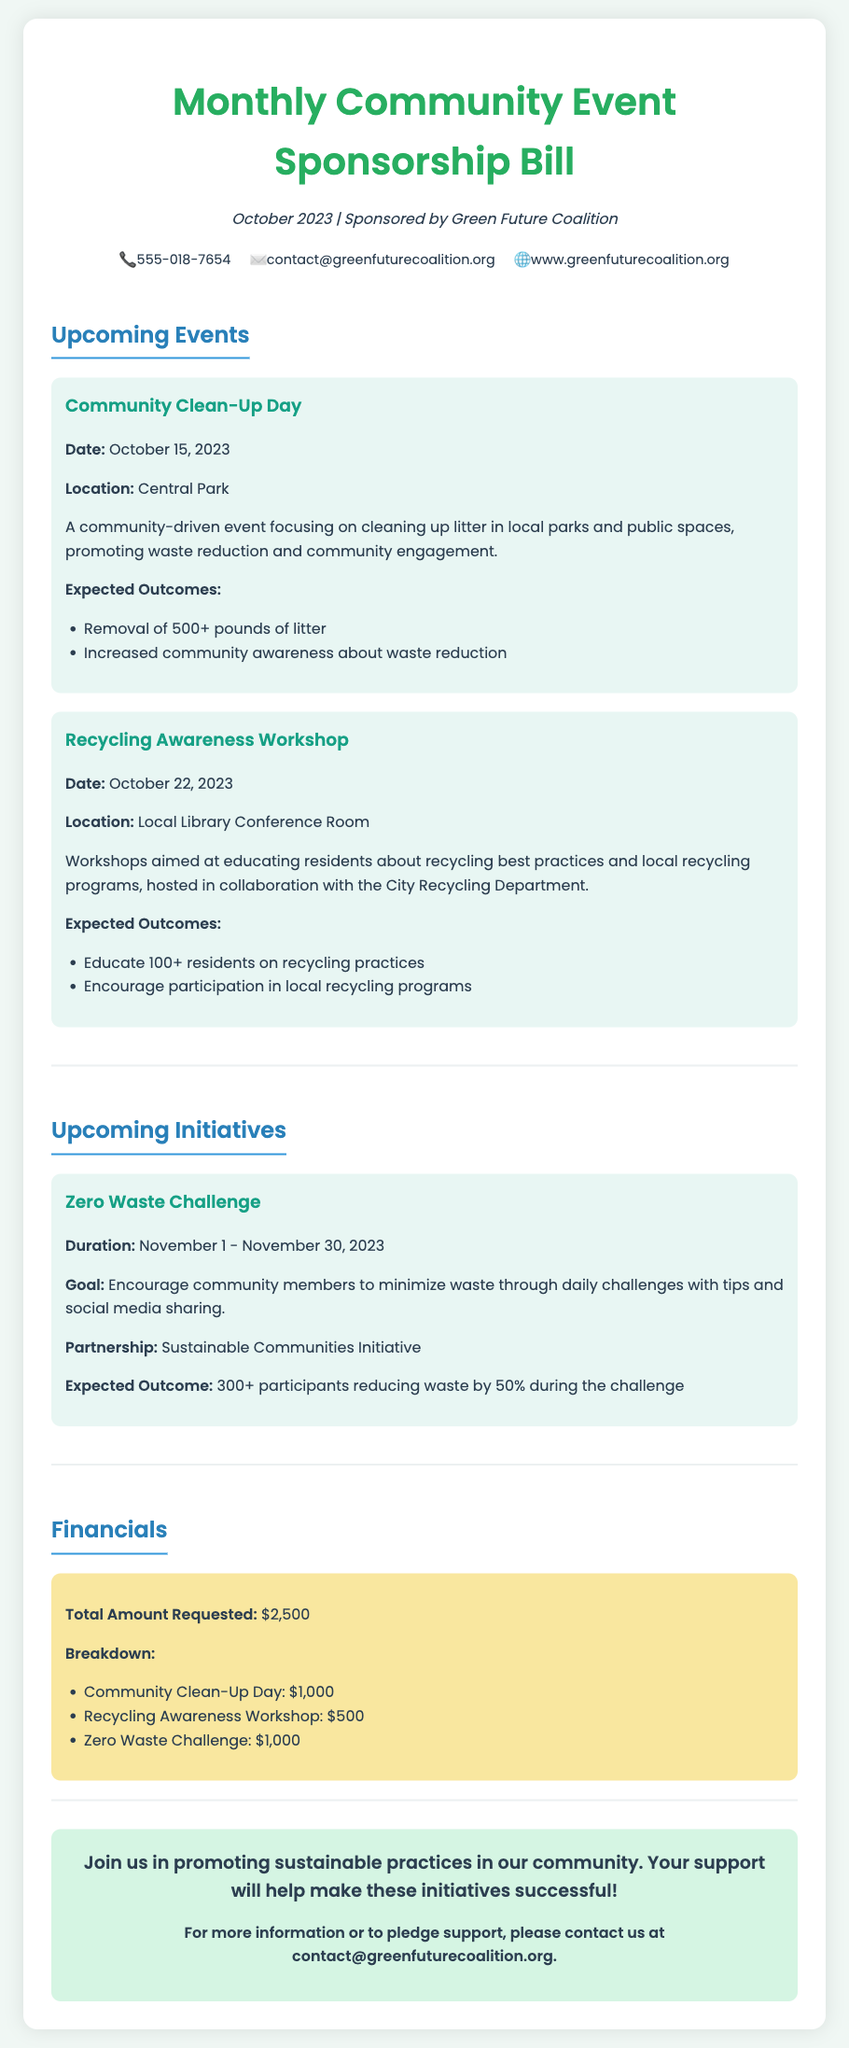What is the date of the Community Clean-Up Day? The date for the Community Clean-Up Day is mentioned in the Upcoming Events section.
Answer: October 15, 2023 What is the total amount requested for the initiatives? The total amount requested is listed in the Financials section.
Answer: $2,500 Where will the Recycling Awareness Workshop be held? The location of the Recycling Awareness Workshop is specified in the Upcoming Events section.
Answer: Local Library Conference Room What is the duration of the Zero Waste Challenge? The duration of the Zero Waste Challenge is provided in the Upcoming Initiatives section.
Answer: November 1 - November 30, 2023 How many residents are expected to participate in the Recycling Awareness Workshop? The expected outcomes for the workshop detail the number of residents anticipated to be educated.
Answer: 100+ What is the goal of the Zero Waste Challenge? The goal of the Zero Waste Challenge is described in the Upcoming Initiatives section.
Answer: Encourage community members to minimize waste What is one expected outcome of the Community Clean-Up Day? The expected outcomes of the Community Clean-Up Day include specific measurable results stated in the document.
Answer: Removal of 500+ pounds of litter Who is sponsoring the Monthly Community Event Sponsorship Bill? The sponsor of the bill is indicated at the top of the document.
Answer: Green Future Coalition 